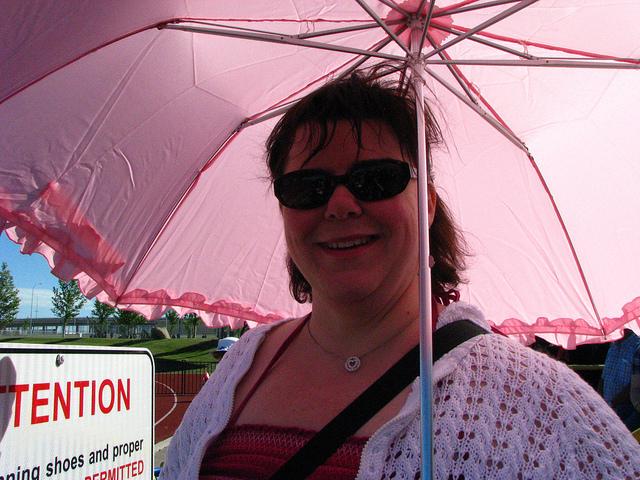What color is her umbrella?
Answer briefly. Pink. Why does she have an umbrella?
Be succinct. Sun. Where are they at?
Give a very brief answer. Golf course. 